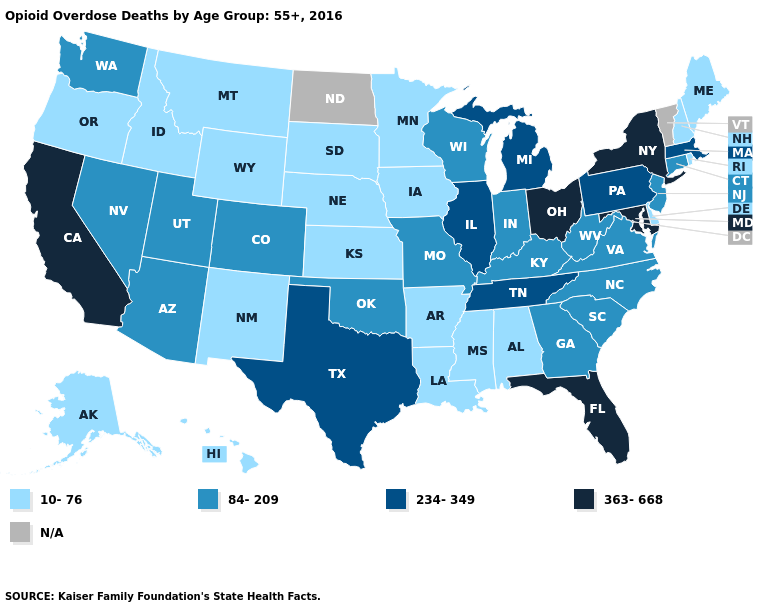Name the states that have a value in the range 234-349?
Quick response, please. Illinois, Massachusetts, Michigan, Pennsylvania, Tennessee, Texas. What is the value of North Carolina?
Concise answer only. 84-209. What is the value of Tennessee?
Short answer required. 234-349. What is the value of Georgia?
Be succinct. 84-209. Does Michigan have the lowest value in the MidWest?
Give a very brief answer. No. How many symbols are there in the legend?
Concise answer only. 5. Does Ohio have the highest value in the USA?
Give a very brief answer. Yes. What is the highest value in the MidWest ?
Concise answer only. 363-668. Name the states that have a value in the range 84-209?
Be succinct. Arizona, Colorado, Connecticut, Georgia, Indiana, Kentucky, Missouri, Nevada, New Jersey, North Carolina, Oklahoma, South Carolina, Utah, Virginia, Washington, West Virginia, Wisconsin. What is the value of Iowa?
Give a very brief answer. 10-76. Does Iowa have the highest value in the MidWest?
Concise answer only. No. Name the states that have a value in the range 234-349?
Give a very brief answer. Illinois, Massachusetts, Michigan, Pennsylvania, Tennessee, Texas. What is the lowest value in the West?
Short answer required. 10-76. Name the states that have a value in the range 234-349?
Keep it brief. Illinois, Massachusetts, Michigan, Pennsylvania, Tennessee, Texas. 